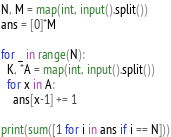<code> <loc_0><loc_0><loc_500><loc_500><_Python_>N, M = map(int, input().split())
ans = [0]*M

for _ in range(N):
  K, *A = map(int, input().split())
  for x in A:
    ans[x-1] += 1

print(sum([1 for i in ans if i == N]))</code> 